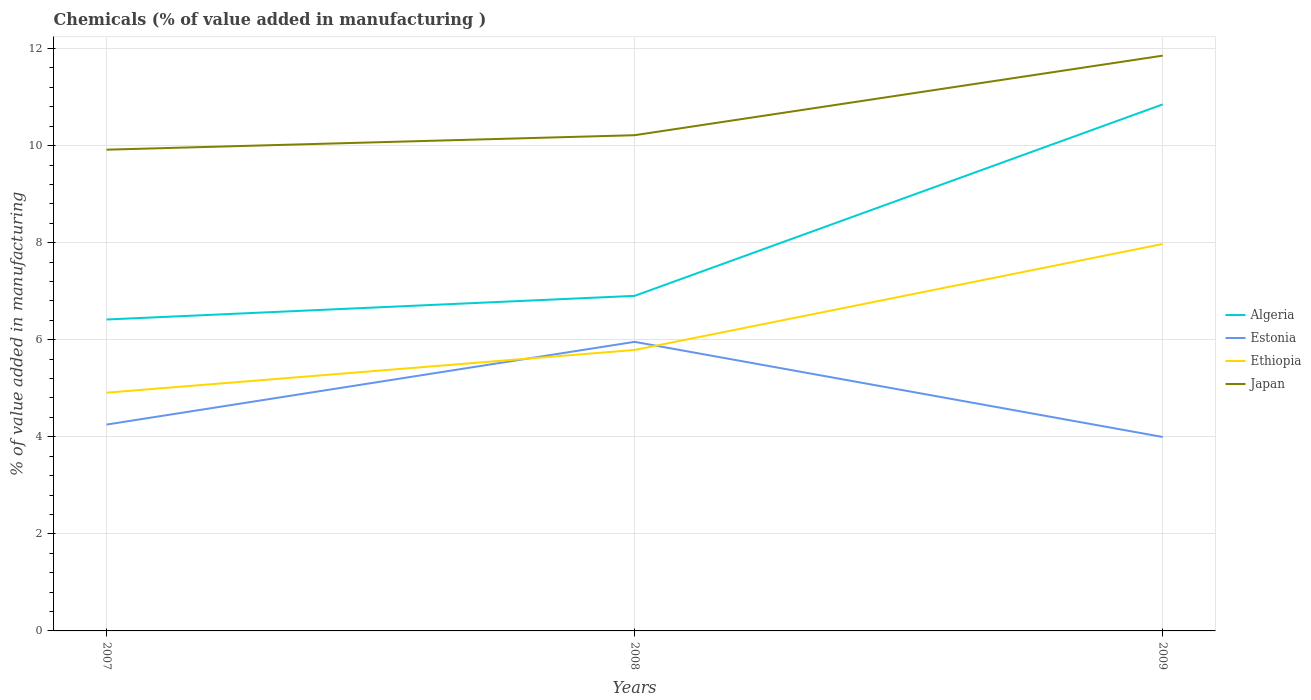Is the number of lines equal to the number of legend labels?
Your answer should be compact. Yes. Across all years, what is the maximum value added in manufacturing chemicals in Algeria?
Give a very brief answer. 6.42. What is the total value added in manufacturing chemicals in Algeria in the graph?
Your response must be concise. -4.43. What is the difference between the highest and the second highest value added in manufacturing chemicals in Japan?
Make the answer very short. 1.94. What is the difference between the highest and the lowest value added in manufacturing chemicals in Ethiopia?
Your answer should be very brief. 1. How many lines are there?
Your answer should be very brief. 4. How many years are there in the graph?
Give a very brief answer. 3. What is the difference between two consecutive major ticks on the Y-axis?
Offer a terse response. 2. Does the graph contain any zero values?
Make the answer very short. No. Where does the legend appear in the graph?
Offer a very short reply. Center right. What is the title of the graph?
Offer a terse response. Chemicals (% of value added in manufacturing ). Does "Myanmar" appear as one of the legend labels in the graph?
Offer a very short reply. No. What is the label or title of the X-axis?
Offer a terse response. Years. What is the label or title of the Y-axis?
Your answer should be very brief. % of value added in manufacturing. What is the % of value added in manufacturing in Algeria in 2007?
Offer a terse response. 6.42. What is the % of value added in manufacturing of Estonia in 2007?
Ensure brevity in your answer.  4.25. What is the % of value added in manufacturing of Ethiopia in 2007?
Give a very brief answer. 4.91. What is the % of value added in manufacturing of Japan in 2007?
Offer a terse response. 9.92. What is the % of value added in manufacturing in Algeria in 2008?
Offer a very short reply. 6.9. What is the % of value added in manufacturing of Estonia in 2008?
Your answer should be very brief. 5.96. What is the % of value added in manufacturing in Ethiopia in 2008?
Your answer should be compact. 5.79. What is the % of value added in manufacturing in Japan in 2008?
Provide a succinct answer. 10.21. What is the % of value added in manufacturing in Algeria in 2009?
Your response must be concise. 10.85. What is the % of value added in manufacturing in Estonia in 2009?
Keep it short and to the point. 4. What is the % of value added in manufacturing of Ethiopia in 2009?
Offer a terse response. 7.97. What is the % of value added in manufacturing in Japan in 2009?
Keep it short and to the point. 11.85. Across all years, what is the maximum % of value added in manufacturing in Algeria?
Provide a short and direct response. 10.85. Across all years, what is the maximum % of value added in manufacturing in Estonia?
Offer a terse response. 5.96. Across all years, what is the maximum % of value added in manufacturing in Ethiopia?
Provide a short and direct response. 7.97. Across all years, what is the maximum % of value added in manufacturing of Japan?
Provide a succinct answer. 11.85. Across all years, what is the minimum % of value added in manufacturing of Algeria?
Make the answer very short. 6.42. Across all years, what is the minimum % of value added in manufacturing in Estonia?
Provide a succinct answer. 4. Across all years, what is the minimum % of value added in manufacturing of Ethiopia?
Make the answer very short. 4.91. Across all years, what is the minimum % of value added in manufacturing in Japan?
Give a very brief answer. 9.92. What is the total % of value added in manufacturing in Algeria in the graph?
Offer a very short reply. 24.17. What is the total % of value added in manufacturing of Estonia in the graph?
Offer a very short reply. 14.2. What is the total % of value added in manufacturing in Ethiopia in the graph?
Your answer should be compact. 18.67. What is the total % of value added in manufacturing in Japan in the graph?
Keep it short and to the point. 31.98. What is the difference between the % of value added in manufacturing in Algeria in 2007 and that in 2008?
Provide a short and direct response. -0.49. What is the difference between the % of value added in manufacturing in Estonia in 2007 and that in 2008?
Keep it short and to the point. -1.7. What is the difference between the % of value added in manufacturing in Ethiopia in 2007 and that in 2008?
Offer a terse response. -0.88. What is the difference between the % of value added in manufacturing in Japan in 2007 and that in 2008?
Give a very brief answer. -0.3. What is the difference between the % of value added in manufacturing of Algeria in 2007 and that in 2009?
Your response must be concise. -4.43. What is the difference between the % of value added in manufacturing of Estonia in 2007 and that in 2009?
Offer a terse response. 0.26. What is the difference between the % of value added in manufacturing of Ethiopia in 2007 and that in 2009?
Offer a terse response. -3.06. What is the difference between the % of value added in manufacturing of Japan in 2007 and that in 2009?
Keep it short and to the point. -1.94. What is the difference between the % of value added in manufacturing in Algeria in 2008 and that in 2009?
Provide a short and direct response. -3.95. What is the difference between the % of value added in manufacturing of Estonia in 2008 and that in 2009?
Offer a terse response. 1.96. What is the difference between the % of value added in manufacturing of Ethiopia in 2008 and that in 2009?
Provide a short and direct response. -2.18. What is the difference between the % of value added in manufacturing in Japan in 2008 and that in 2009?
Provide a short and direct response. -1.64. What is the difference between the % of value added in manufacturing of Algeria in 2007 and the % of value added in manufacturing of Estonia in 2008?
Keep it short and to the point. 0.46. What is the difference between the % of value added in manufacturing of Algeria in 2007 and the % of value added in manufacturing of Ethiopia in 2008?
Your response must be concise. 0.63. What is the difference between the % of value added in manufacturing of Algeria in 2007 and the % of value added in manufacturing of Japan in 2008?
Your answer should be compact. -3.8. What is the difference between the % of value added in manufacturing in Estonia in 2007 and the % of value added in manufacturing in Ethiopia in 2008?
Your response must be concise. -1.54. What is the difference between the % of value added in manufacturing in Estonia in 2007 and the % of value added in manufacturing in Japan in 2008?
Provide a short and direct response. -5.96. What is the difference between the % of value added in manufacturing in Ethiopia in 2007 and the % of value added in manufacturing in Japan in 2008?
Make the answer very short. -5.31. What is the difference between the % of value added in manufacturing of Algeria in 2007 and the % of value added in manufacturing of Estonia in 2009?
Make the answer very short. 2.42. What is the difference between the % of value added in manufacturing in Algeria in 2007 and the % of value added in manufacturing in Ethiopia in 2009?
Make the answer very short. -1.56. What is the difference between the % of value added in manufacturing of Algeria in 2007 and the % of value added in manufacturing of Japan in 2009?
Your response must be concise. -5.44. What is the difference between the % of value added in manufacturing of Estonia in 2007 and the % of value added in manufacturing of Ethiopia in 2009?
Your response must be concise. -3.72. What is the difference between the % of value added in manufacturing in Estonia in 2007 and the % of value added in manufacturing in Japan in 2009?
Offer a terse response. -7.6. What is the difference between the % of value added in manufacturing in Ethiopia in 2007 and the % of value added in manufacturing in Japan in 2009?
Make the answer very short. -6.94. What is the difference between the % of value added in manufacturing in Algeria in 2008 and the % of value added in manufacturing in Estonia in 2009?
Provide a short and direct response. 2.91. What is the difference between the % of value added in manufacturing of Algeria in 2008 and the % of value added in manufacturing of Ethiopia in 2009?
Make the answer very short. -1.07. What is the difference between the % of value added in manufacturing in Algeria in 2008 and the % of value added in manufacturing in Japan in 2009?
Your answer should be compact. -4.95. What is the difference between the % of value added in manufacturing in Estonia in 2008 and the % of value added in manufacturing in Ethiopia in 2009?
Your answer should be very brief. -2.02. What is the difference between the % of value added in manufacturing of Estonia in 2008 and the % of value added in manufacturing of Japan in 2009?
Offer a very short reply. -5.9. What is the difference between the % of value added in manufacturing in Ethiopia in 2008 and the % of value added in manufacturing in Japan in 2009?
Provide a short and direct response. -6.06. What is the average % of value added in manufacturing in Algeria per year?
Your answer should be very brief. 8.06. What is the average % of value added in manufacturing in Estonia per year?
Make the answer very short. 4.73. What is the average % of value added in manufacturing in Ethiopia per year?
Offer a terse response. 6.22. What is the average % of value added in manufacturing of Japan per year?
Your response must be concise. 10.66. In the year 2007, what is the difference between the % of value added in manufacturing in Algeria and % of value added in manufacturing in Estonia?
Ensure brevity in your answer.  2.17. In the year 2007, what is the difference between the % of value added in manufacturing of Algeria and % of value added in manufacturing of Ethiopia?
Offer a terse response. 1.51. In the year 2007, what is the difference between the % of value added in manufacturing in Algeria and % of value added in manufacturing in Japan?
Your answer should be very brief. -3.5. In the year 2007, what is the difference between the % of value added in manufacturing of Estonia and % of value added in manufacturing of Ethiopia?
Offer a terse response. -0.66. In the year 2007, what is the difference between the % of value added in manufacturing in Estonia and % of value added in manufacturing in Japan?
Provide a succinct answer. -5.66. In the year 2007, what is the difference between the % of value added in manufacturing of Ethiopia and % of value added in manufacturing of Japan?
Offer a very short reply. -5.01. In the year 2008, what is the difference between the % of value added in manufacturing in Algeria and % of value added in manufacturing in Estonia?
Your response must be concise. 0.95. In the year 2008, what is the difference between the % of value added in manufacturing of Algeria and % of value added in manufacturing of Ethiopia?
Provide a short and direct response. 1.11. In the year 2008, what is the difference between the % of value added in manufacturing in Algeria and % of value added in manufacturing in Japan?
Offer a very short reply. -3.31. In the year 2008, what is the difference between the % of value added in manufacturing in Estonia and % of value added in manufacturing in Ethiopia?
Provide a succinct answer. 0.17. In the year 2008, what is the difference between the % of value added in manufacturing of Estonia and % of value added in manufacturing of Japan?
Provide a short and direct response. -4.26. In the year 2008, what is the difference between the % of value added in manufacturing of Ethiopia and % of value added in manufacturing of Japan?
Offer a terse response. -4.42. In the year 2009, what is the difference between the % of value added in manufacturing in Algeria and % of value added in manufacturing in Estonia?
Ensure brevity in your answer.  6.85. In the year 2009, what is the difference between the % of value added in manufacturing of Algeria and % of value added in manufacturing of Ethiopia?
Give a very brief answer. 2.88. In the year 2009, what is the difference between the % of value added in manufacturing of Algeria and % of value added in manufacturing of Japan?
Keep it short and to the point. -1. In the year 2009, what is the difference between the % of value added in manufacturing of Estonia and % of value added in manufacturing of Ethiopia?
Your response must be concise. -3.98. In the year 2009, what is the difference between the % of value added in manufacturing of Estonia and % of value added in manufacturing of Japan?
Your answer should be compact. -7.86. In the year 2009, what is the difference between the % of value added in manufacturing in Ethiopia and % of value added in manufacturing in Japan?
Offer a terse response. -3.88. What is the ratio of the % of value added in manufacturing of Algeria in 2007 to that in 2008?
Your answer should be compact. 0.93. What is the ratio of the % of value added in manufacturing of Estonia in 2007 to that in 2008?
Offer a terse response. 0.71. What is the ratio of the % of value added in manufacturing of Ethiopia in 2007 to that in 2008?
Offer a terse response. 0.85. What is the ratio of the % of value added in manufacturing of Japan in 2007 to that in 2008?
Provide a succinct answer. 0.97. What is the ratio of the % of value added in manufacturing in Algeria in 2007 to that in 2009?
Make the answer very short. 0.59. What is the ratio of the % of value added in manufacturing in Estonia in 2007 to that in 2009?
Make the answer very short. 1.06. What is the ratio of the % of value added in manufacturing in Ethiopia in 2007 to that in 2009?
Offer a terse response. 0.62. What is the ratio of the % of value added in manufacturing of Japan in 2007 to that in 2009?
Your answer should be compact. 0.84. What is the ratio of the % of value added in manufacturing in Algeria in 2008 to that in 2009?
Keep it short and to the point. 0.64. What is the ratio of the % of value added in manufacturing in Estonia in 2008 to that in 2009?
Give a very brief answer. 1.49. What is the ratio of the % of value added in manufacturing of Ethiopia in 2008 to that in 2009?
Keep it short and to the point. 0.73. What is the ratio of the % of value added in manufacturing in Japan in 2008 to that in 2009?
Provide a succinct answer. 0.86. What is the difference between the highest and the second highest % of value added in manufacturing of Algeria?
Provide a short and direct response. 3.95. What is the difference between the highest and the second highest % of value added in manufacturing in Estonia?
Your answer should be compact. 1.7. What is the difference between the highest and the second highest % of value added in manufacturing in Ethiopia?
Ensure brevity in your answer.  2.18. What is the difference between the highest and the second highest % of value added in manufacturing of Japan?
Provide a short and direct response. 1.64. What is the difference between the highest and the lowest % of value added in manufacturing of Algeria?
Make the answer very short. 4.43. What is the difference between the highest and the lowest % of value added in manufacturing in Estonia?
Offer a very short reply. 1.96. What is the difference between the highest and the lowest % of value added in manufacturing of Ethiopia?
Provide a succinct answer. 3.06. What is the difference between the highest and the lowest % of value added in manufacturing in Japan?
Make the answer very short. 1.94. 